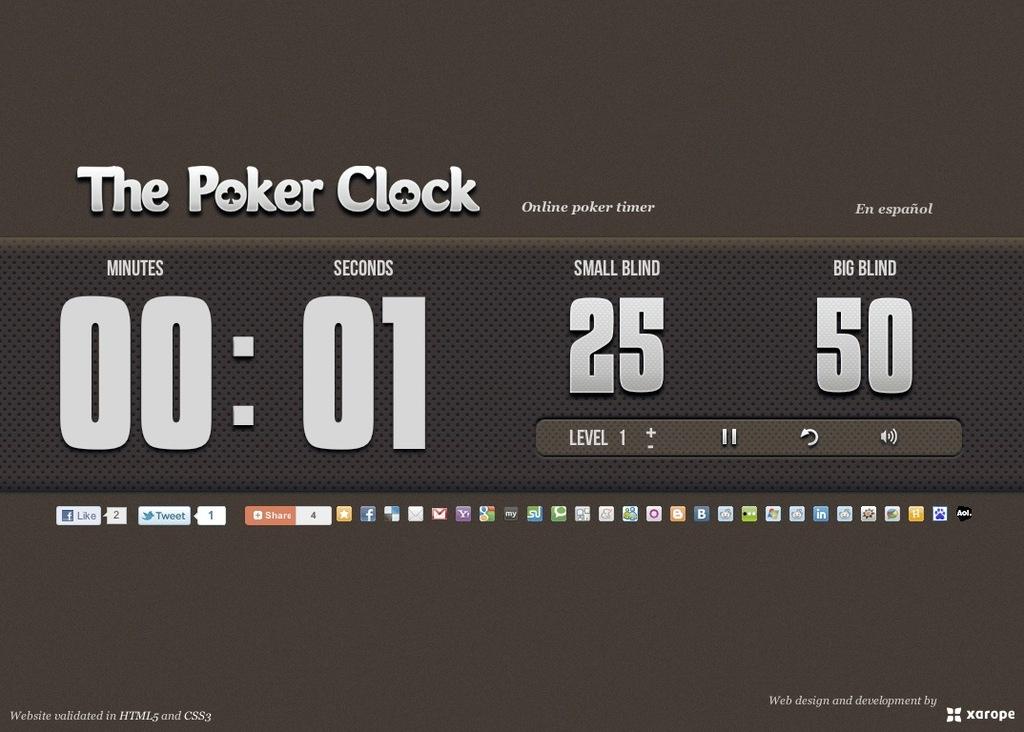How much is the big blind?
Offer a very short reply. 50. What is this site called?
Provide a short and direct response. The poker clock. 